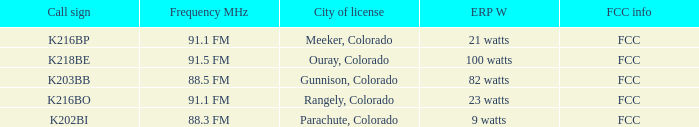Which ERP W has a Frequency MHz of 88.5 FM? 82 watts. 